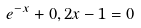<formula> <loc_0><loc_0><loc_500><loc_500>e ^ { - x } + 0 , 2 x - 1 = 0</formula> 